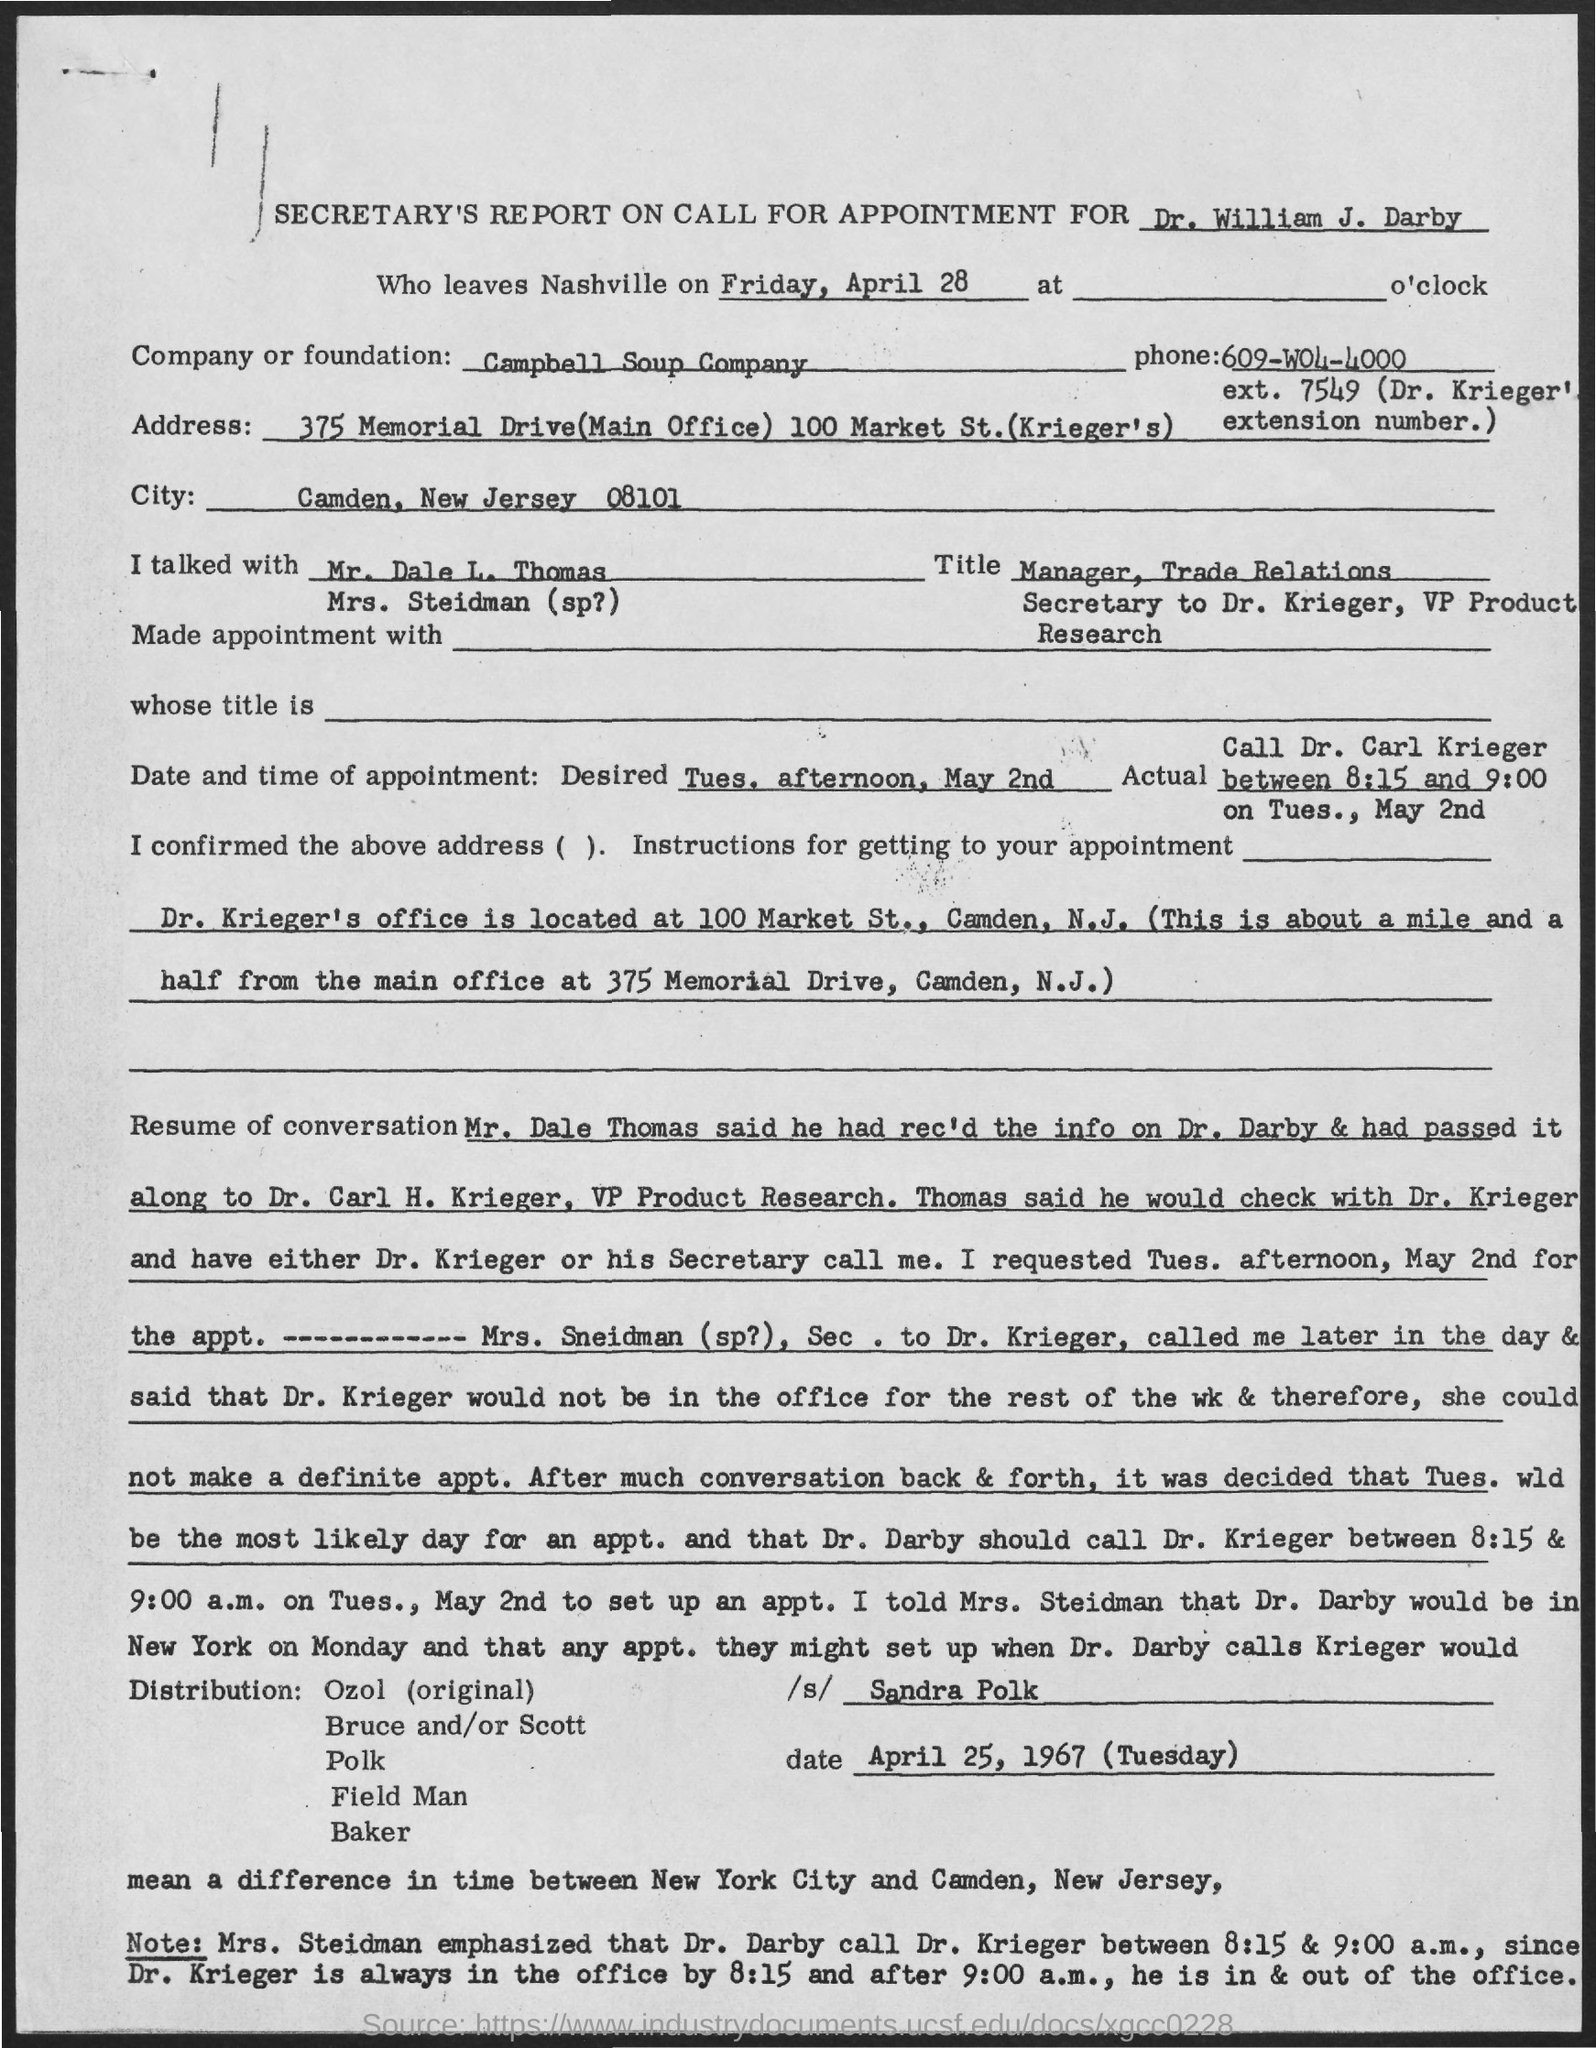Identify some key points in this picture. The Campbell Soup Company is mentioned in the document. 